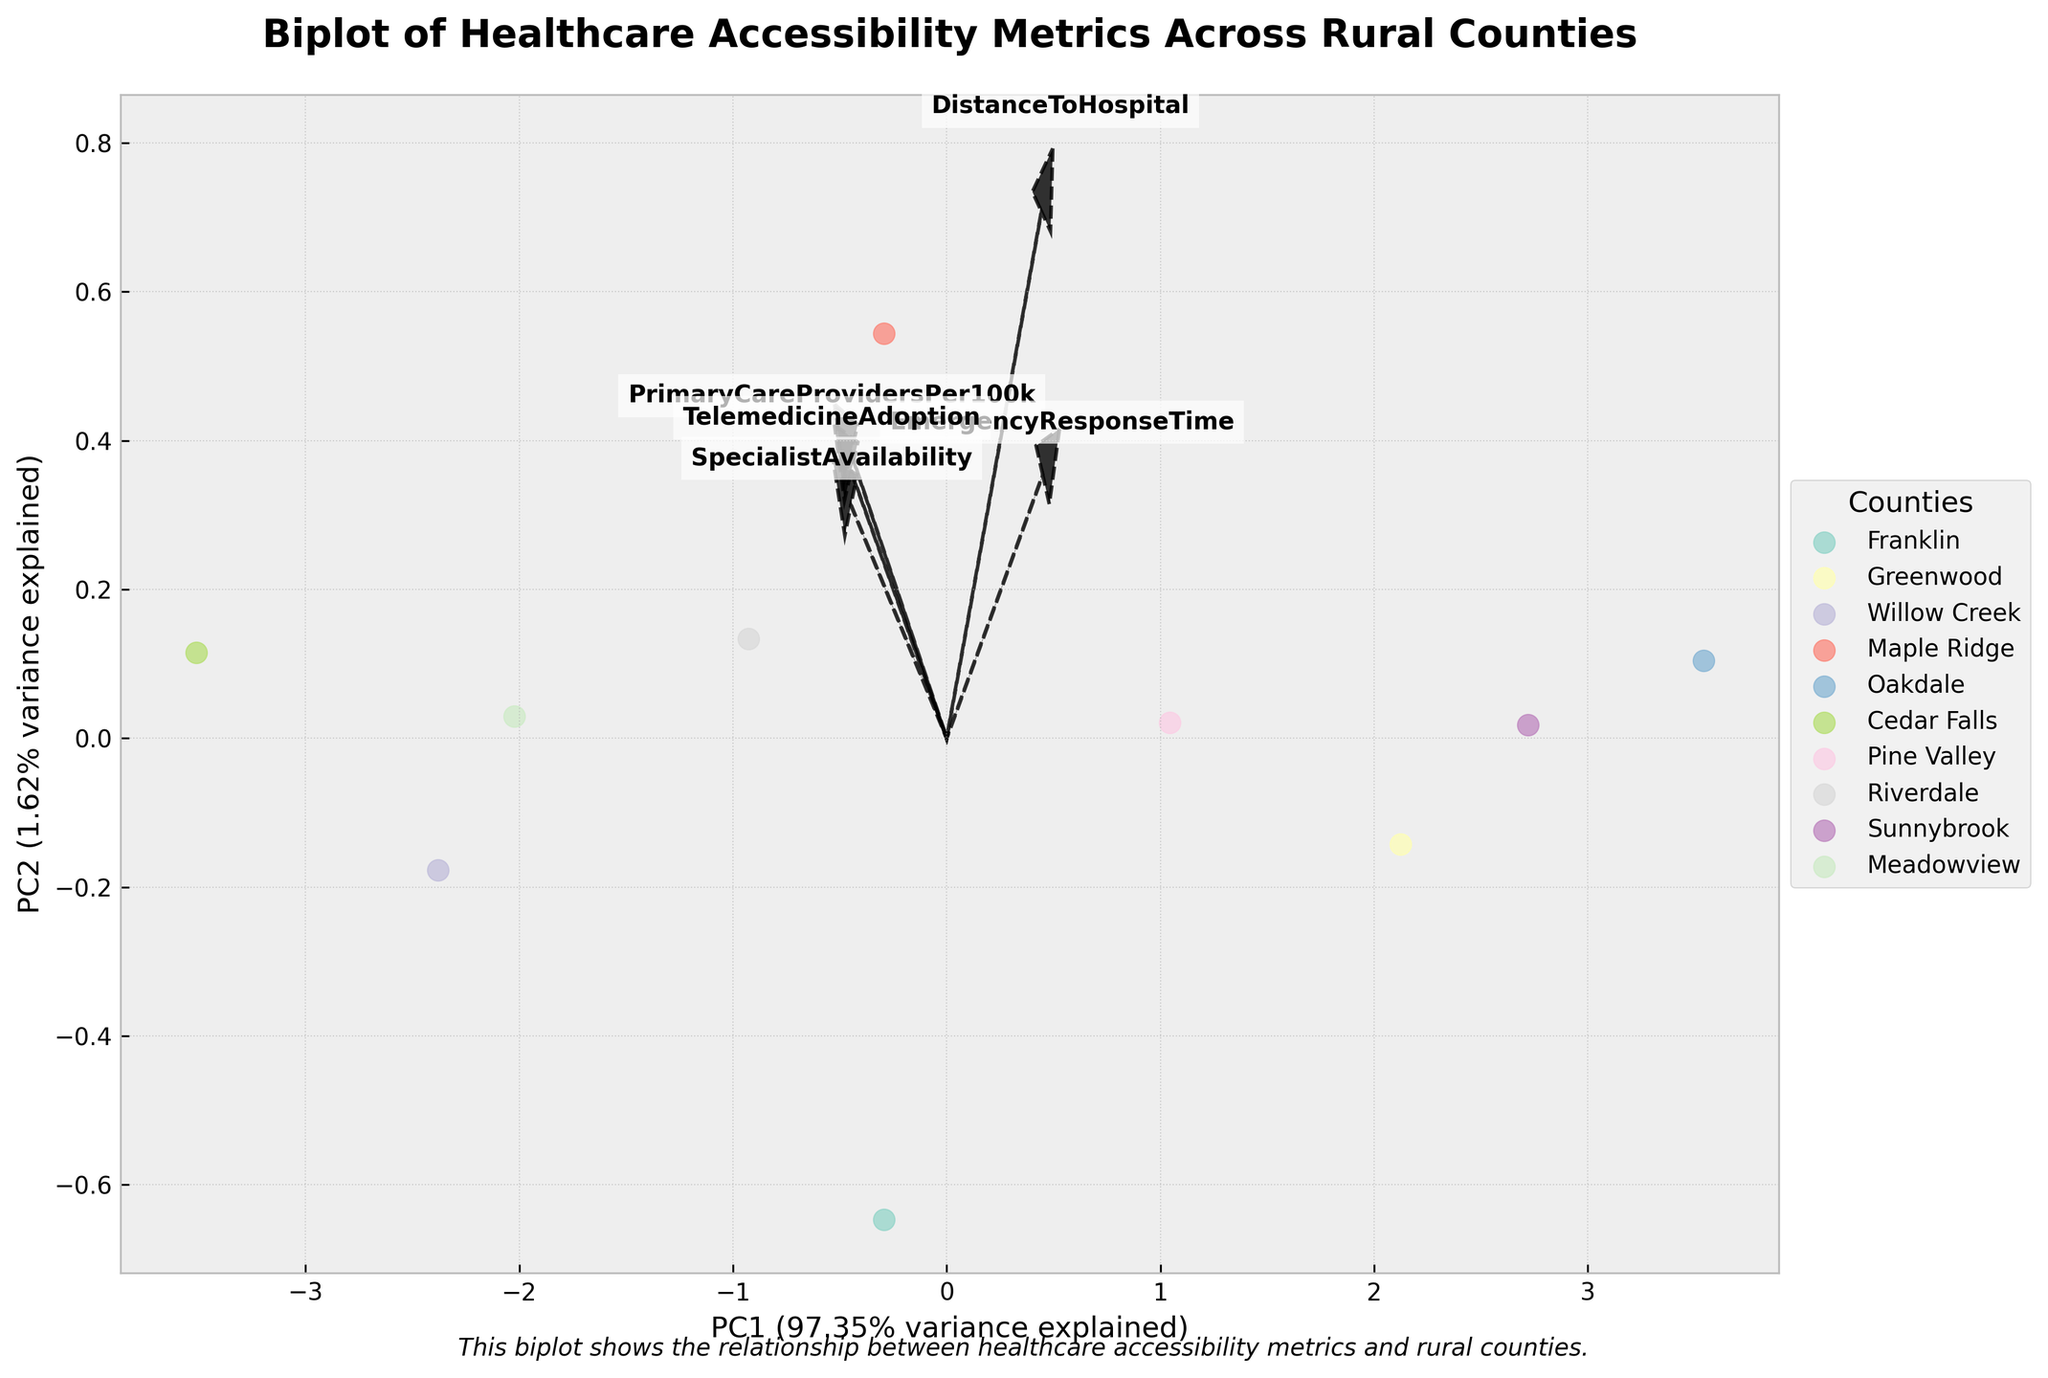How many counties are represented in the biplot? You can count the number of unique markers or labels representing different counties in the plot.
Answer: 10 Which county appears to be the farthest from the primary component axes intersection in the biplot? By examining the distances from the origin (intersection of PC1 and PC2 axes), Oakdale appears to be the farthest point.
Answer: Oakdale Which metric has the largest positive impact on PC1? Check the feature vectors' directions; the longest arrow in the positive direction along PC1 indicates the feature with the largest positive impact.
Answer: PrimaryCareProvidersPer100k Which two healthcare metrics seem most correlated based on their vector directions? Look for feature vectors that point in the same or very similar directions; they will likely reflect correlated metrics.
Answer: PrimaryCareProvidersPer100k and TelemedicineAdoption Which counties have particularly low specialist availability and high distance to hospitals simultaneously? Compare the counties' positions relative to the directions of the DistanceToHospital and SpecialistAvailability vectors. Counties in the direction of high DistanceToHospital and low SpecialistAvailability would fit this description.
Answer: Oakdale, Sunnybrook Which feature vector is pointing in the opposite direction to 'EmergencyResponseTime'? An opposite direction implies the vectors are nearly 180 degrees apart. Identify the vector pointing almost directly opposite to the 'EmergencyResponseTime' vector.
Answer: SpecialistAvailability How much variance is explained by the first principal component (PC1)? Check the x-axis label, which mentions the variance explained by PC1.
Answer: Around 36% Are any counties located close to the intersection of the PC1 and PC2 axes? Examine the plot and check for markers that are near the origin (0,0) where PC1 and PC2 intersect.
Answer: Cedar Falls and Willow Creek Which county has the highest adoption of telemedicine services, based on the direction of the TelemedicineAdoption vector? Identify which marker (county) lies farthest in the direction of the TelemedicineAdoption vector.
Answer: Cedar Falls Which counties have both high primary care providers per 100k and short emergency response time? Look for counties in the direction of both the PrimaryCareProvidersPer100k and EmergencyResponseTime vectors.
Answer: Cedar Falls, Willow Creek 